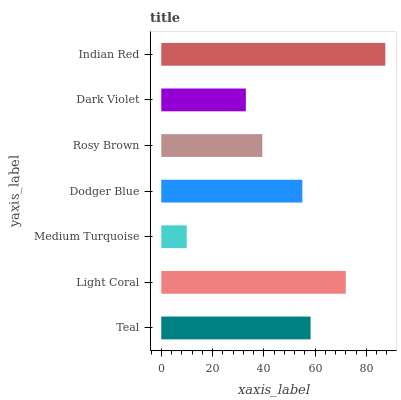Is Medium Turquoise the minimum?
Answer yes or no. Yes. Is Indian Red the maximum?
Answer yes or no. Yes. Is Light Coral the minimum?
Answer yes or no. No. Is Light Coral the maximum?
Answer yes or no. No. Is Light Coral greater than Teal?
Answer yes or no. Yes. Is Teal less than Light Coral?
Answer yes or no. Yes. Is Teal greater than Light Coral?
Answer yes or no. No. Is Light Coral less than Teal?
Answer yes or no. No. Is Dodger Blue the high median?
Answer yes or no. Yes. Is Dodger Blue the low median?
Answer yes or no. Yes. Is Indian Red the high median?
Answer yes or no. No. Is Indian Red the low median?
Answer yes or no. No. 